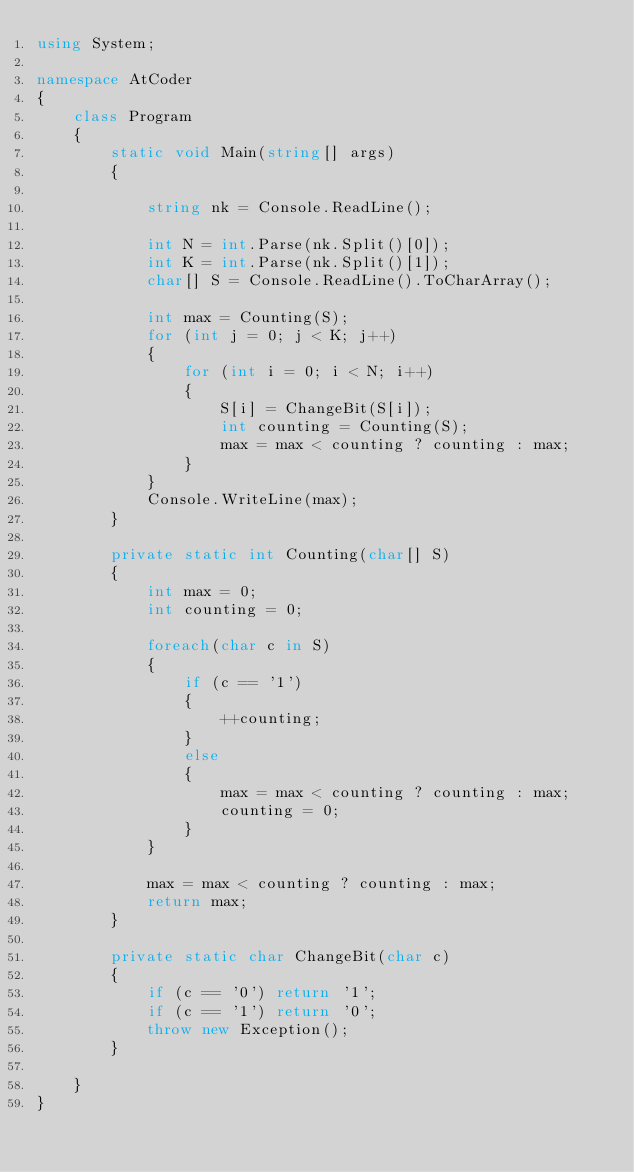Convert code to text. <code><loc_0><loc_0><loc_500><loc_500><_C#_>using System;

namespace AtCoder
{
    class Program
    {
        static void Main(string[] args)
        {

            string nk = Console.ReadLine();

            int N = int.Parse(nk.Split()[0]);
            int K = int.Parse(nk.Split()[1]);
            char[] S = Console.ReadLine().ToCharArray();

            int max = Counting(S);
            for (int j = 0; j < K; j++)
            {
                for (int i = 0; i < N; i++)
                {
                    S[i] = ChangeBit(S[i]);
                    int counting = Counting(S);
                    max = max < counting ? counting : max;
                }
            }
            Console.WriteLine(max);
        }

        private static int Counting(char[] S)
        {
            int max = 0;
            int counting = 0;

            foreach(char c in S)
            {
                if (c == '1')
                {
                    ++counting;
                }
                else
                {
                    max = max < counting ? counting : max;
                    counting = 0;
                }
            }

            max = max < counting ? counting : max;
            return max;
        }

        private static char ChangeBit(char c)
        {
            if (c == '0') return '1';
            if (c == '1') return '0';
            throw new Exception();
        }

    }
}
</code> 